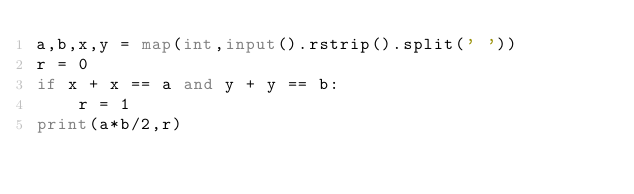<code> <loc_0><loc_0><loc_500><loc_500><_Python_>a,b,x,y = map(int,input().rstrip().split(' '))
r = 0
if x + x == a and y + y == b:
    r = 1
print(a*b/2,r)</code> 